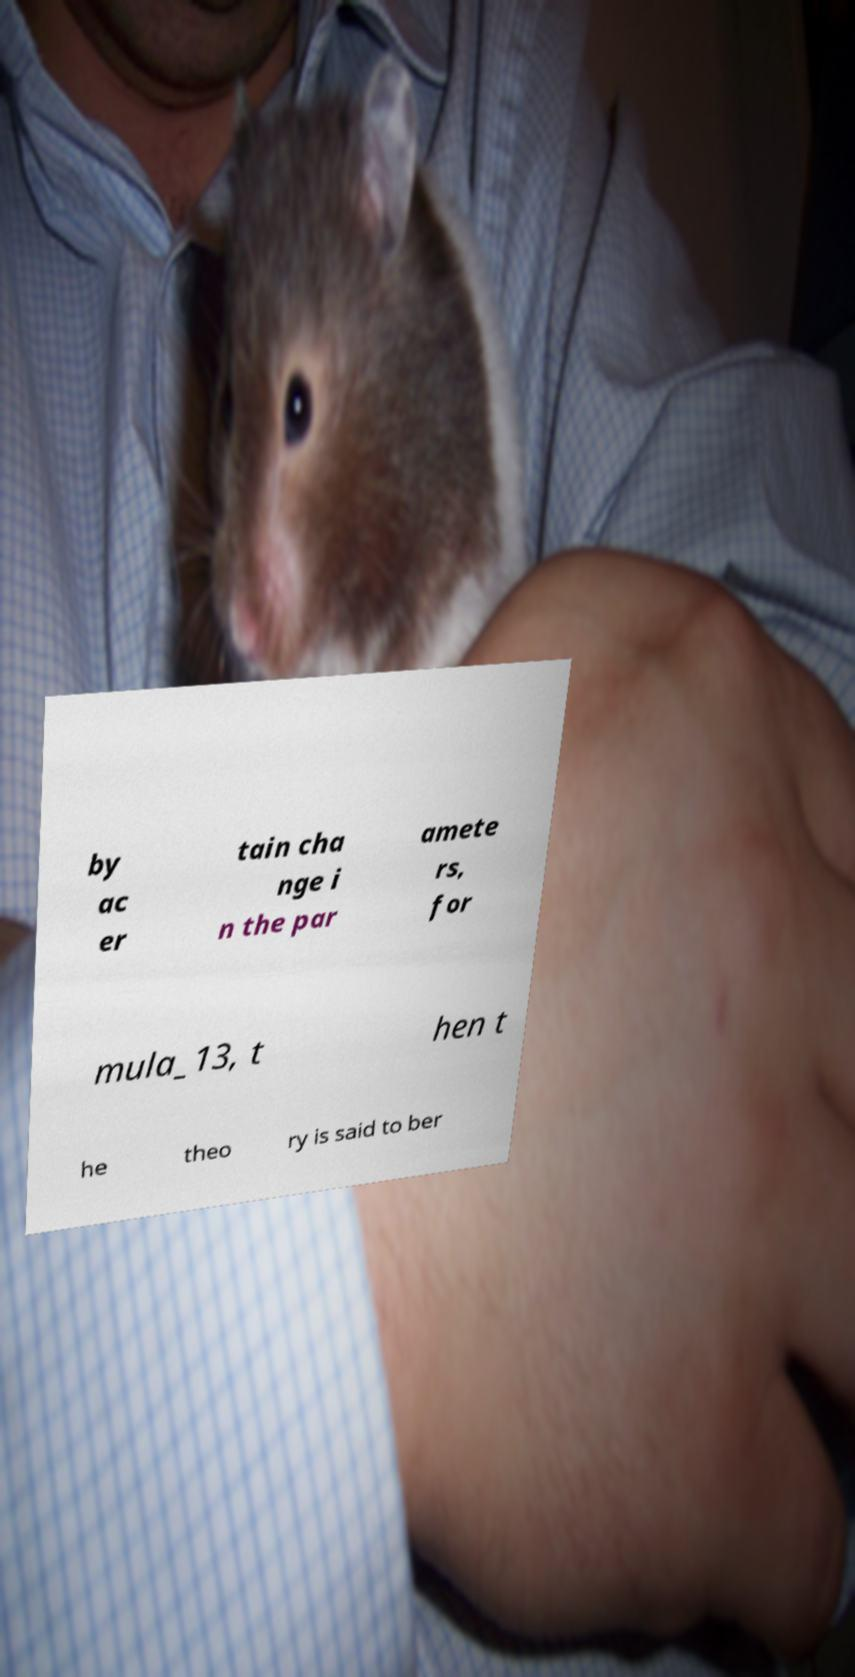Can you accurately transcribe the text from the provided image for me? by ac er tain cha nge i n the par amete rs, for mula_13, t hen t he theo ry is said to ber 